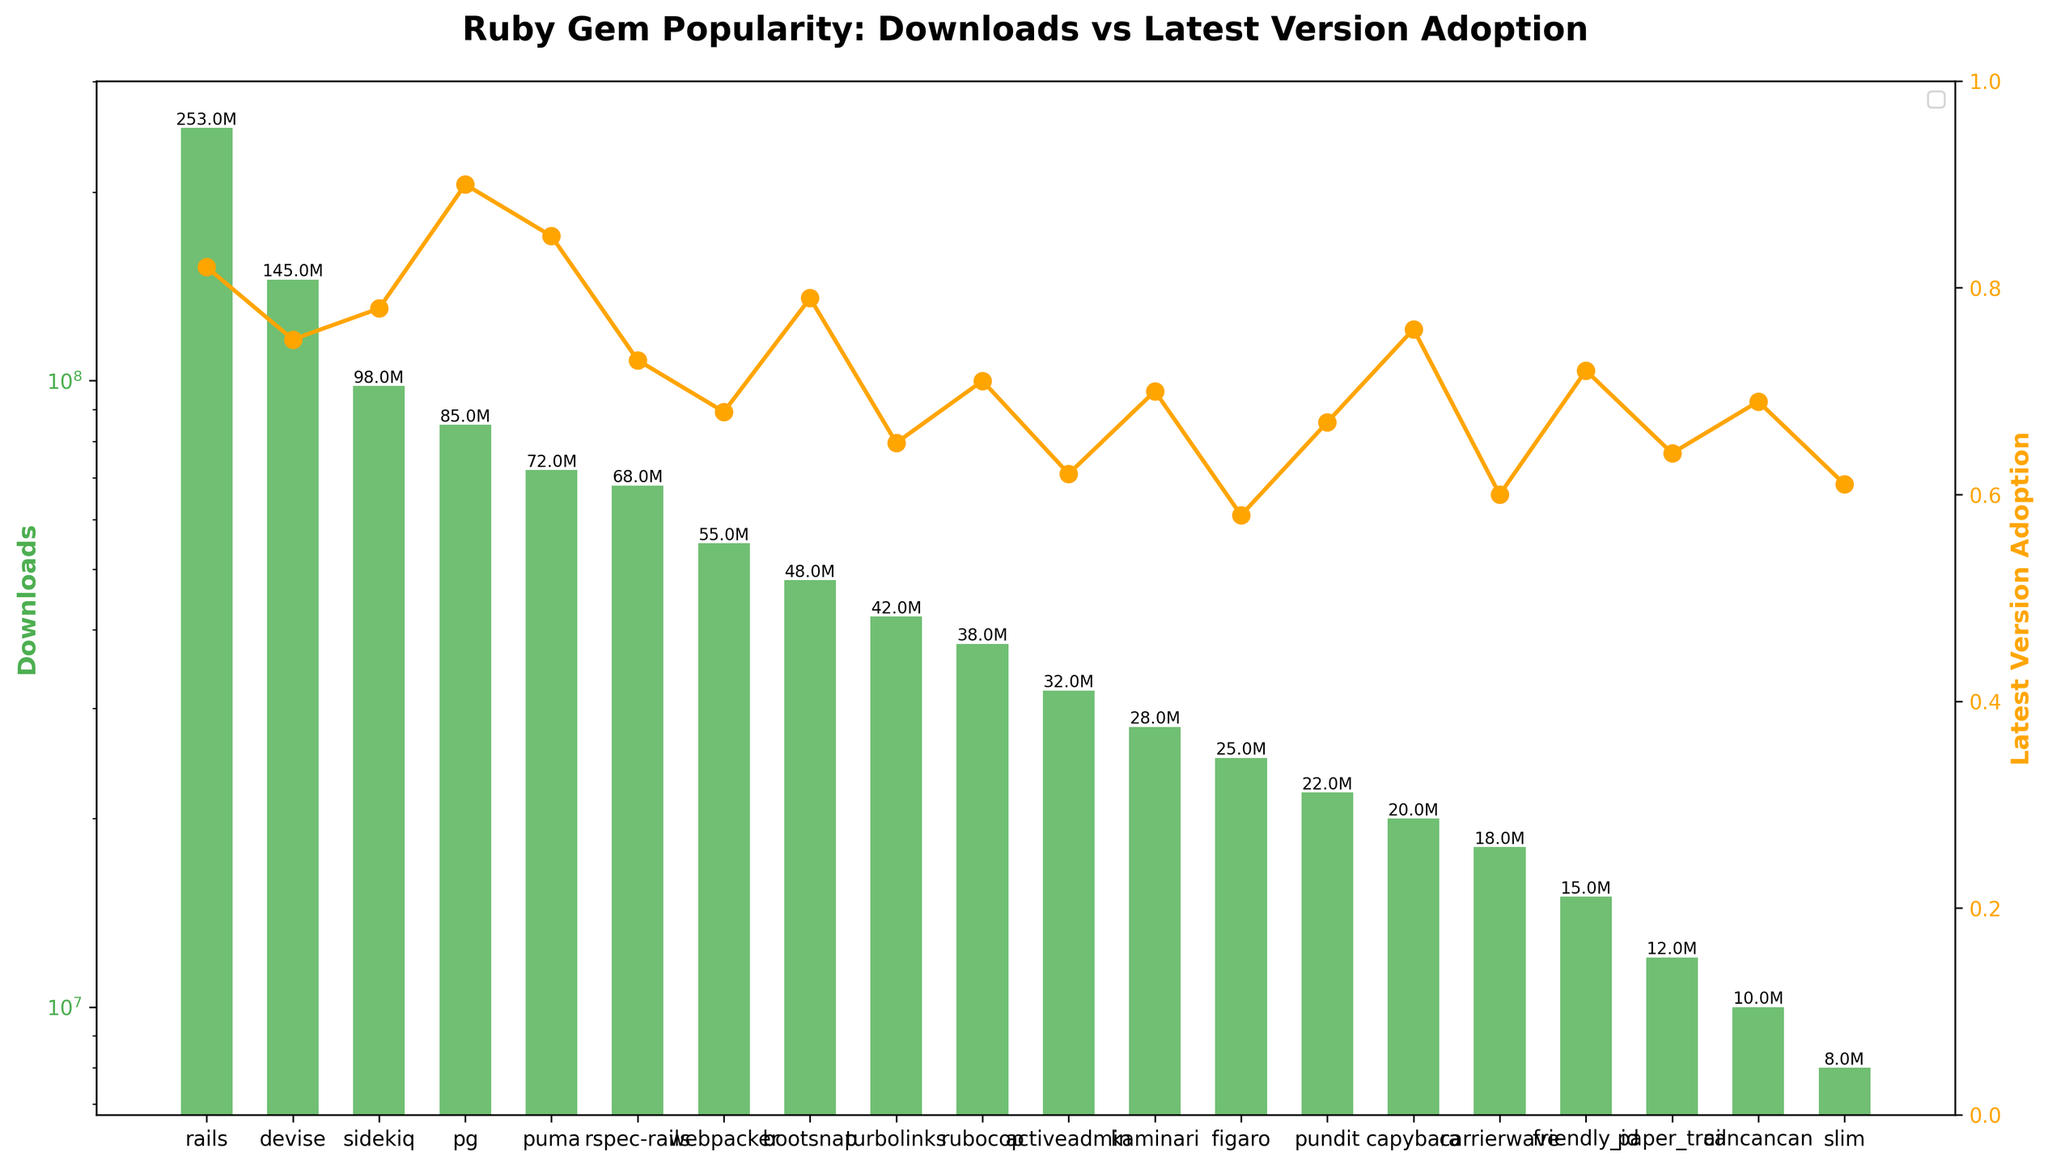Which Ruby gem has the highest download count? The figure reveals that the tallest green bar, representing the download count for each gem, is for 'rails'. This indicates that 'rails' has the highest download count.
Answer: rails What is the latest version adoption rate for 'sidekiq'? By looking at the orange line marker corresponding to 'sidekiq', we can see the value on the right y-axis. The figure shows that the latest version adoption rate for 'sidekiq' is at 0.78.
Answer: 0.78 Which gem has a higher latest version adoption rate, 'puma' or 'rspec-rails'? Comparing the orange line markers for 'puma' and 'rspec-rails', we find that 'puma' has an adoption rate of 0.85, whereas 'rspec-rails' shows 0.73.
Answer: puma How many gems have a latest version adoption rate greater than 0.80? By inspecting the orange line markers and counting those that are above the 0.80 mark, we observe that three gems (rails, pg, and puma) have a latest version adoption rate greater than 0.80.
Answer: 3 What is the combined download count for the gems 'devise' and 'pg'? The figure shows that 'devise' has 145 million downloads and 'pg' has 85 million downloads. Summing these values gives 145M + 85M = 230M.
Answer: 230 million Which gem has the lowest download count? The shortest green bar in the figure corresponds to 'slim', indicating that it has the lowest download count among the listed gems.
Answer: slim What is the median latest version adoption rate among all listed gems? Arranging the latest version adoption rates in ascending order: 0.58, 0.60, 0.61, 0.62, 0.64, 0.65, 0.67, 0.68, 0.69, 0.70, 0.71, 0.72, 0.73, 0.75, 0.76, 0.78, 0.79, 0.82, 0.85, 0.90. The median is the average of the 10th and 11th values: (0.70 + 0.71)/2 = 0.705.
Answer: 0.705 Which has more downloads, 'bootsnap' or 'rubocop'? The figure's green bars illustrate that 'bootsnap' has 48 million downloads and 'rubocop' has 38 million downloads. Therefore, 'bootsnap' has more downloads.
Answer: bootsnap Are there more gems with a download count higher than 100 million or fewer than 20 million? By counting the green bars higher than 100 million (rails, devise, sidekiq) and those lower than 20 million (capybara, carrierwave, friendly_id, paper_trail, cancancan, slim), there are 3 gems with more than 100 million downloads and 6 with fewer than 20 million.
Answer: fewer than 20 million 